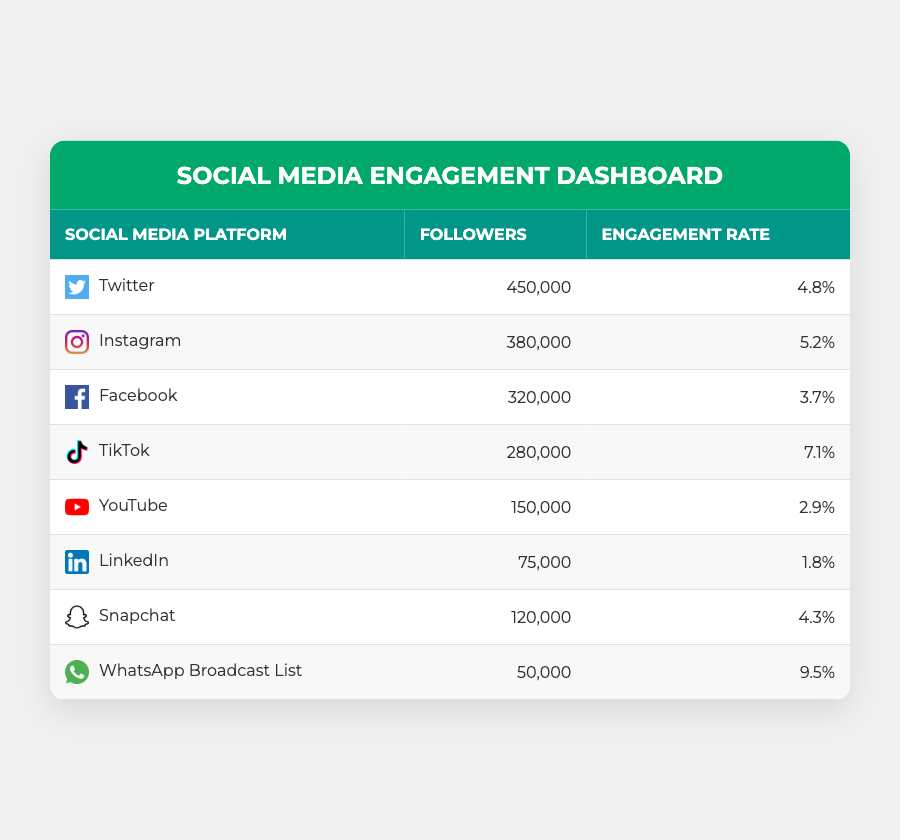What is the total number of followers across all social media platforms? To find the total number of followers, we need to add the followers from each platform: 450000 (Twitter) + 380000 (Instagram) + 320000 (Facebook) + 280000 (TikTok) + 150000 (YouTube) + 75000 (LinkedIn) + 120000 (Snapchat) + 50000 (WhatsApp) = 1,750,000
Answer: 1,750,000 Which platform has the highest engagement rate? By comparing the engagement rates listed, TikTok has the highest engagement rate at 7.1%
Answer: TikTok Is the engagement rate for Instagram higher than that of Facebook? Instagram has an engagement rate of 5.2% while Facebook has 3.7%. Since 5.2% is greater than 3.7%, the statement is true
Answer: Yes How many followers does WhatsApp Broadcast List have compared to YouTube? WhatsApp Broadcast List has 50,000 followers while YouTube has 150,000 followers. Therefore, YouTube has 150,000 - 50,000 = 100,000 more followers than WhatsApp Broadcast List
Answer: 100,000 What is the average engagement rate for all platforms? To find the average engagement rate, we first convert the percentages to decimal format: 4.8, 5.2, 3.7, 7.1, 2.9, 1.8, 4.3, 9.5. Adding these gives 39.3 and then dividing by 8 (the number of platforms) provides an average of 39.3 / 8 = 4.9125, which is approximately 4.91%
Answer: 4.91% 